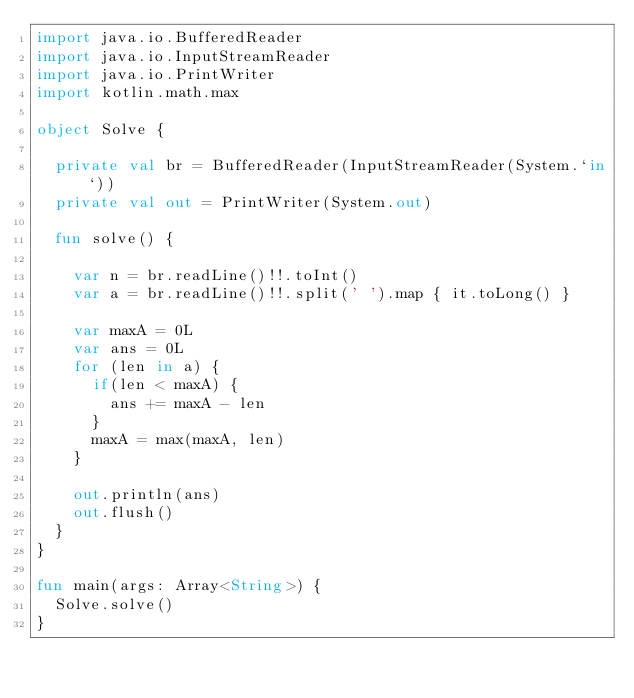<code> <loc_0><loc_0><loc_500><loc_500><_Kotlin_>import java.io.BufferedReader
import java.io.InputStreamReader
import java.io.PrintWriter
import kotlin.math.max

object Solve {

  private val br = BufferedReader(InputStreamReader(System.`in`))
  private val out = PrintWriter(System.out)

  fun solve() {

    var n = br.readLine()!!.toInt()
    var a = br.readLine()!!.split(' ').map { it.toLong() }

    var maxA = 0L
    var ans = 0L
    for (len in a) {
      if(len < maxA) {
        ans += maxA - len
      }
      maxA = max(maxA, len)
    }

    out.println(ans)
    out.flush()
  }
}

fun main(args: Array<String>) {
  Solve.solve()
}</code> 